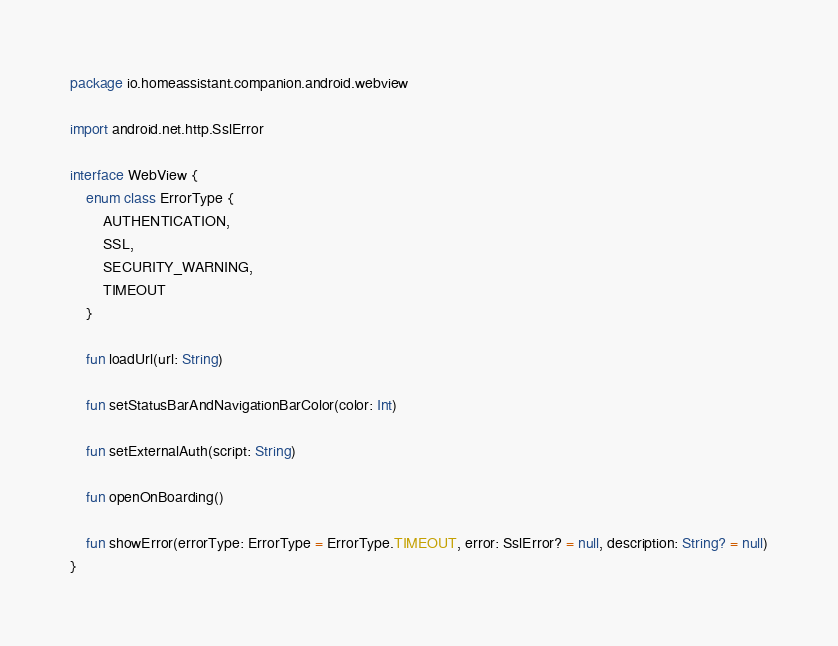<code> <loc_0><loc_0><loc_500><loc_500><_Kotlin_>package io.homeassistant.companion.android.webview

import android.net.http.SslError

interface WebView {
    enum class ErrorType {
        AUTHENTICATION,
        SSL,
        SECURITY_WARNING,
        TIMEOUT
    }

    fun loadUrl(url: String)

    fun setStatusBarAndNavigationBarColor(color: Int)

    fun setExternalAuth(script: String)

    fun openOnBoarding()

    fun showError(errorType: ErrorType = ErrorType.TIMEOUT, error: SslError? = null, description: String? = null)
}
</code> 